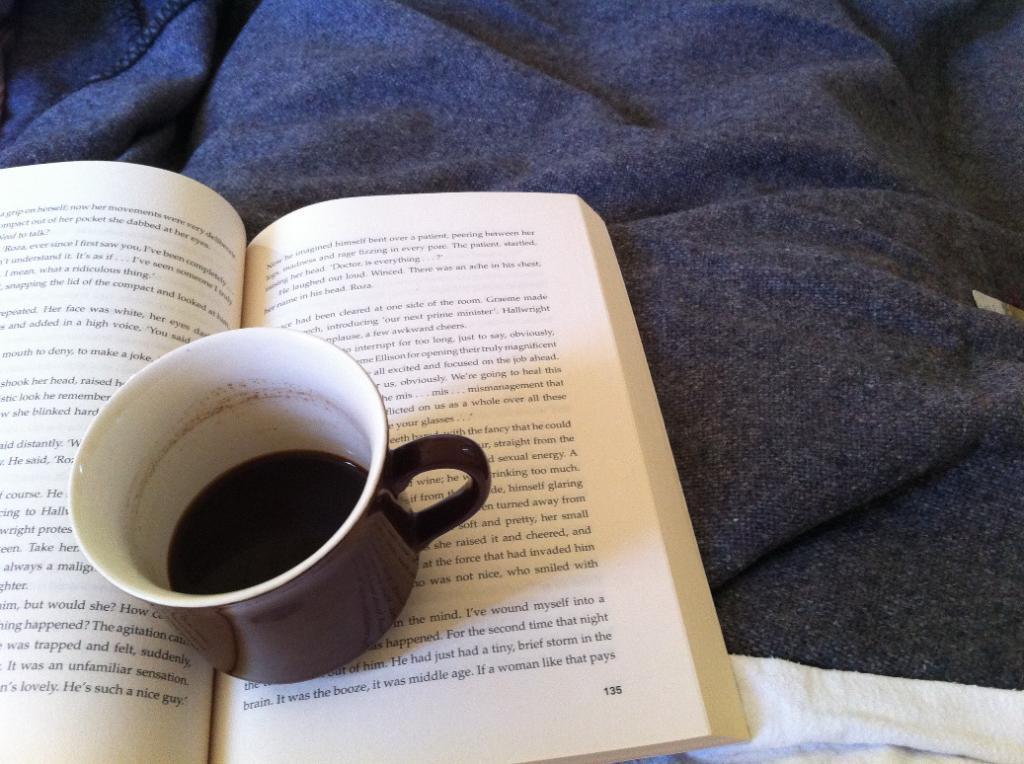Describe this image in one or two sentences. In the image,there is a book kept on a bed sheet and on the book there is a cup containing some drink is kept. 